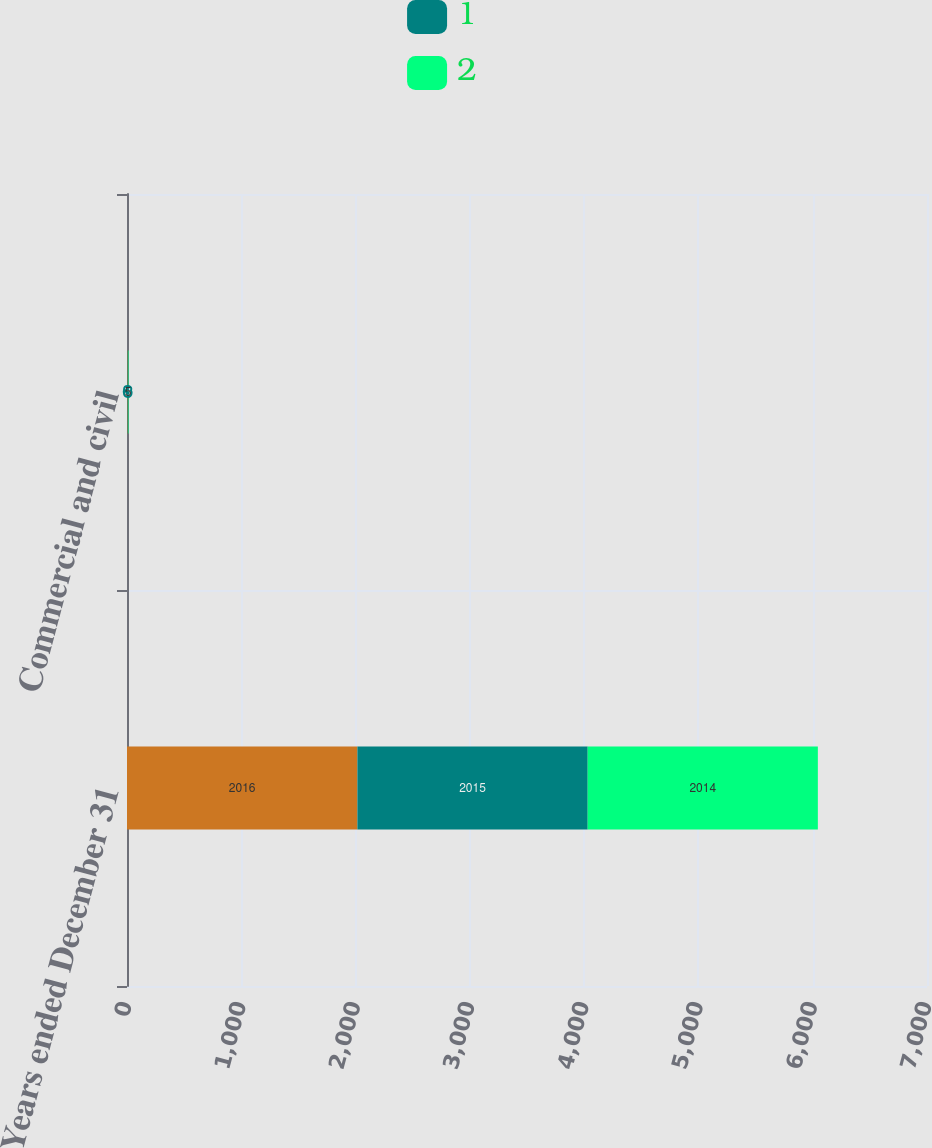Convert chart. <chart><loc_0><loc_0><loc_500><loc_500><stacked_bar_chart><ecel><fcel>Years ended December 31<fcel>Commercial and civil<nl><fcel>nan<fcel>2016<fcel>5<nl><fcel>1<fcel>2015<fcel>3<nl><fcel>2<fcel>2014<fcel>5<nl></chart> 